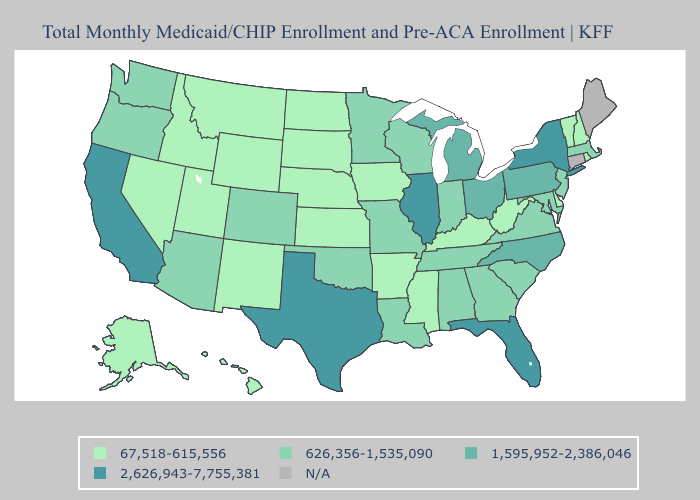Does the first symbol in the legend represent the smallest category?
Be succinct. Yes. Does Texas have the highest value in the USA?
Write a very short answer. Yes. What is the highest value in states that border Indiana?
Quick response, please. 2,626,943-7,755,381. Which states have the highest value in the USA?
Give a very brief answer. California, Florida, Illinois, New York, Texas. Which states have the lowest value in the USA?
Keep it brief. Alaska, Arkansas, Delaware, Hawaii, Idaho, Iowa, Kansas, Kentucky, Mississippi, Montana, Nebraska, Nevada, New Hampshire, New Mexico, North Dakota, Rhode Island, South Dakota, Utah, Vermont, West Virginia, Wyoming. Among the states that border Minnesota , does Wisconsin have the lowest value?
Keep it brief. No. What is the lowest value in the South?
Give a very brief answer. 67,518-615,556. Name the states that have a value in the range 1,595,952-2,386,046?
Keep it brief. Michigan, North Carolina, Ohio, Pennsylvania. What is the highest value in the Northeast ?
Keep it brief. 2,626,943-7,755,381. What is the value of Oregon?
Keep it brief. 626,356-1,535,090. Does Michigan have the highest value in the USA?
Quick response, please. No. Name the states that have a value in the range 2,626,943-7,755,381?
Write a very short answer. California, Florida, Illinois, New York, Texas. Among the states that border Illinois , which have the highest value?
Write a very short answer. Indiana, Missouri, Wisconsin. Name the states that have a value in the range 67,518-615,556?
Give a very brief answer. Alaska, Arkansas, Delaware, Hawaii, Idaho, Iowa, Kansas, Kentucky, Mississippi, Montana, Nebraska, Nevada, New Hampshire, New Mexico, North Dakota, Rhode Island, South Dakota, Utah, Vermont, West Virginia, Wyoming. 